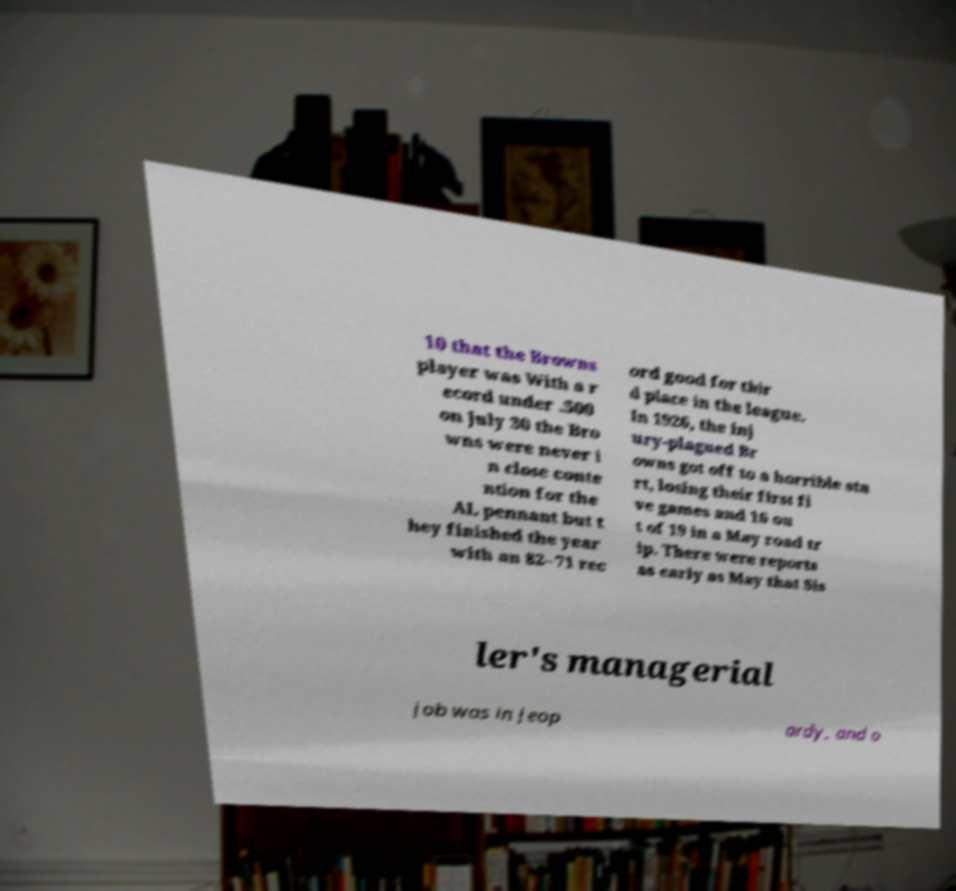Please identify and transcribe the text found in this image. 10 that the Browns player was With a r ecord under .500 on July 30 the Bro wns were never i n close conte ntion for the AL pennant but t hey finished the year with an 82–71 rec ord good for thir d place in the league. In 1926, the inj ury-plagued Br owns got off to a horrible sta rt, losing their first fi ve games and 16 ou t of 19 in a May road tr ip. There were reports as early as May that Sis ler's managerial job was in jeop ardy, and o 